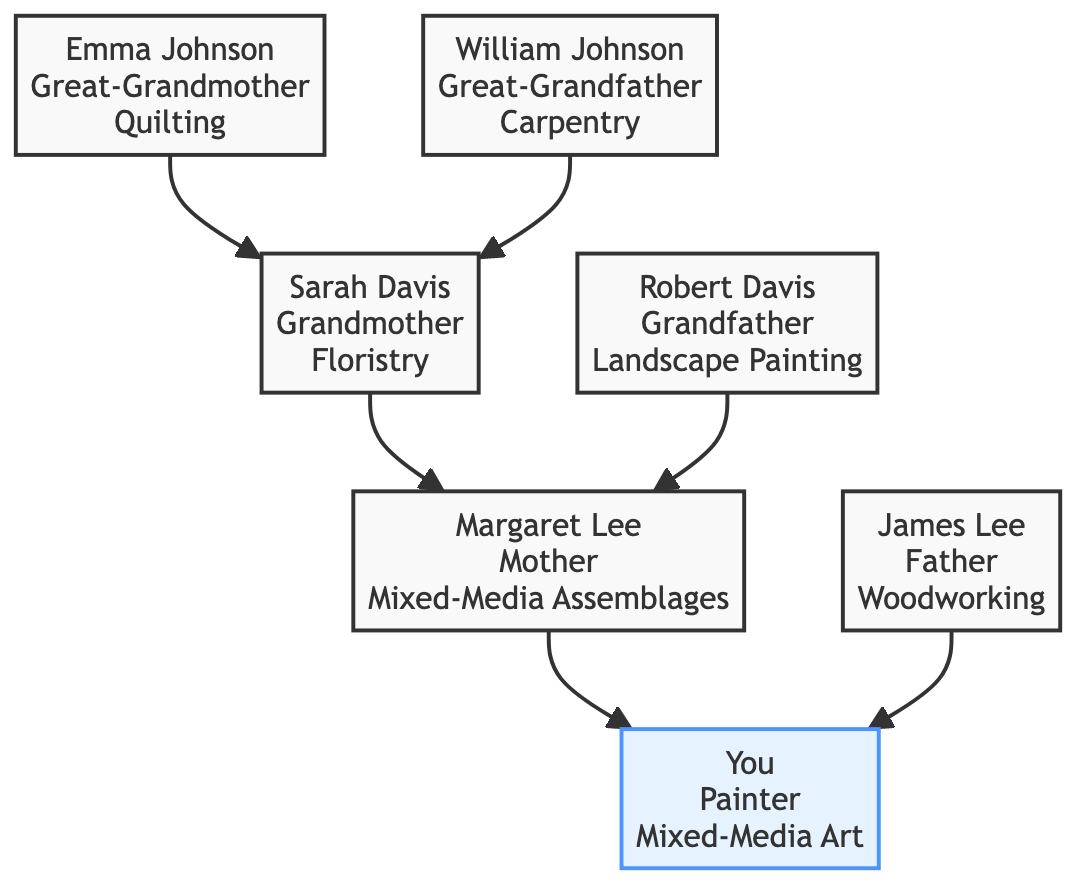What contribution did Emma Johnson make to the family? The diagram shows that Emma Johnson contributed "Quilting Techniques" to the family.
Answer: Quilting Techniques Who is the father in the family tree? According to the diagram, the father is James Lee.
Answer: James Lee What type of artwork does Sarah Davis create? The diagram states that Sarah Davis creates "Flower arrangements and pressed flower collages."
Answer: Flower arrangements and pressed flower collages How many generations are represented in the family tree? By examining the diagram, we see there are four generations: great-grandparents, grandparents, parents, and you.
Answer: Four What influence did William Johnson have on art? The influence from William Johnson is indicated as "Incorporated wood framing and sculpting techniques into art."
Answer: Incorporated wood framing and sculpting techniques into art Which family member is indicated as a painter? The diagram specifies that you are the painter in the family.
Answer: You What is the relationship between Margaret Lee and Robert Davis? The diagram connects Margaret Lee and Robert Davis through their child, which makes them "in-laws."
Answer: In-laws What specific artwork did James Lee contribute to the family? James Lee is credited in the diagram with creating "Handcrafted wooden toys and sculptures."
Answer: Handcrafted wooden toys and sculptures What is the main focus of your artistic contribution? Based on the diagram, your main focus is "Mixed-Media Art."
Answer: Mixed-Media Art 